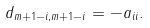Convert formula to latex. <formula><loc_0><loc_0><loc_500><loc_500>d _ { m + 1 - i , m + 1 - i } = - a _ { i i } .</formula> 